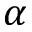Convert formula to latex. <formula><loc_0><loc_0><loc_500><loc_500>\alpha</formula> 